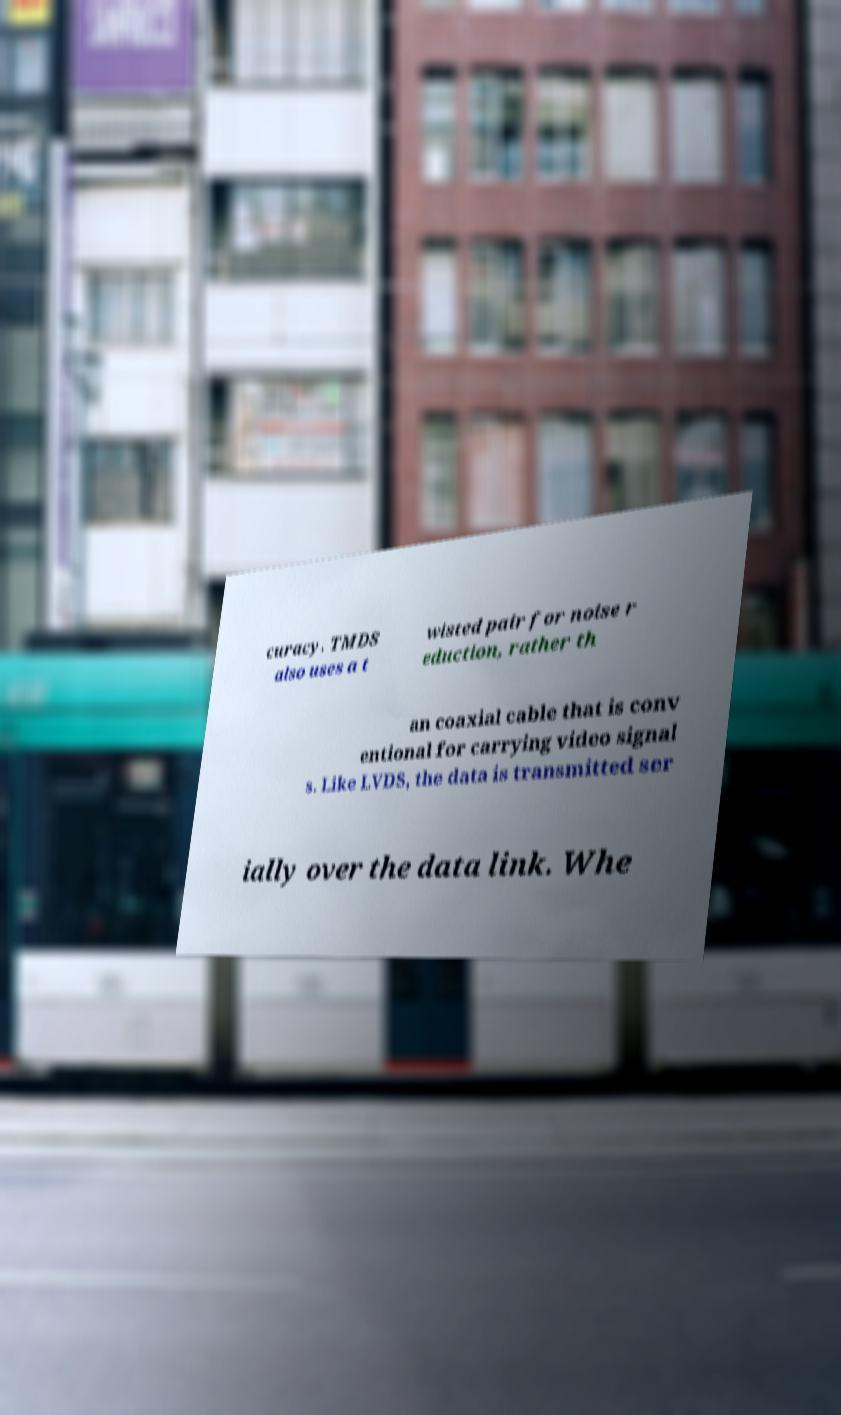There's text embedded in this image that I need extracted. Can you transcribe it verbatim? curacy. TMDS also uses a t wisted pair for noise r eduction, rather th an coaxial cable that is conv entional for carrying video signal s. Like LVDS, the data is transmitted ser ially over the data link. Whe 